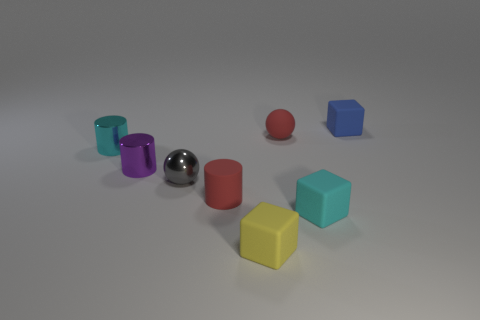Add 2 yellow matte cubes. How many objects exist? 10 Subtract all cubes. How many objects are left? 5 Subtract all tiny things. Subtract all big blue matte things. How many objects are left? 0 Add 5 tiny gray shiny spheres. How many tiny gray shiny spheres are left? 6 Add 1 big gray shiny spheres. How many big gray shiny spheres exist? 1 Subtract 1 blue blocks. How many objects are left? 7 